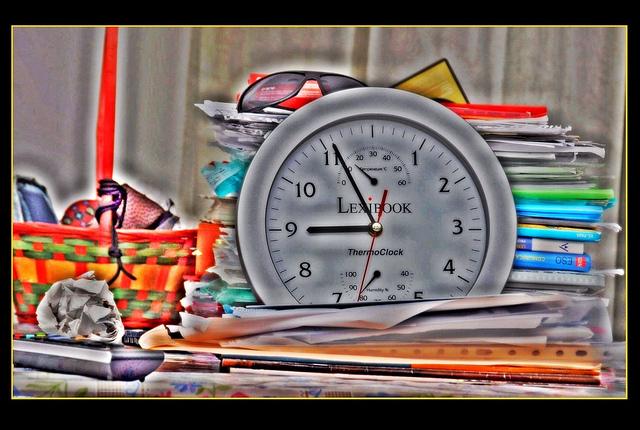Is the picture in neon?
Keep it brief. Yes. What time is on the clock?
Be succinct. 8:56. Has this image been edited or altered?
Quick response, please. Yes. 